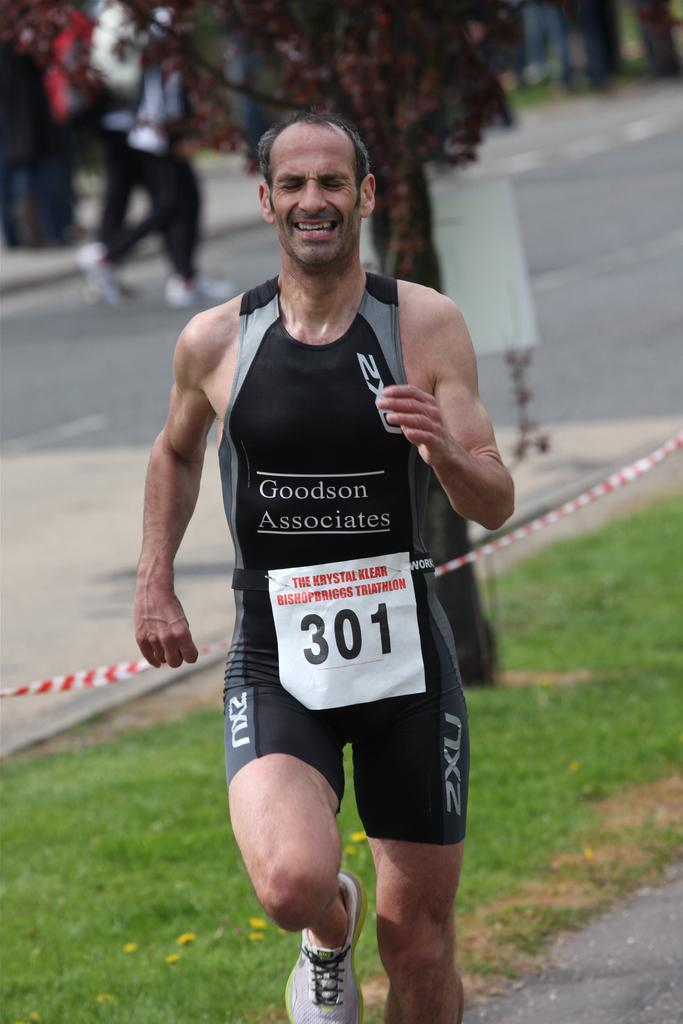Provide a one-sentence caption for the provided image. A runner with the number 301 on his vest. 